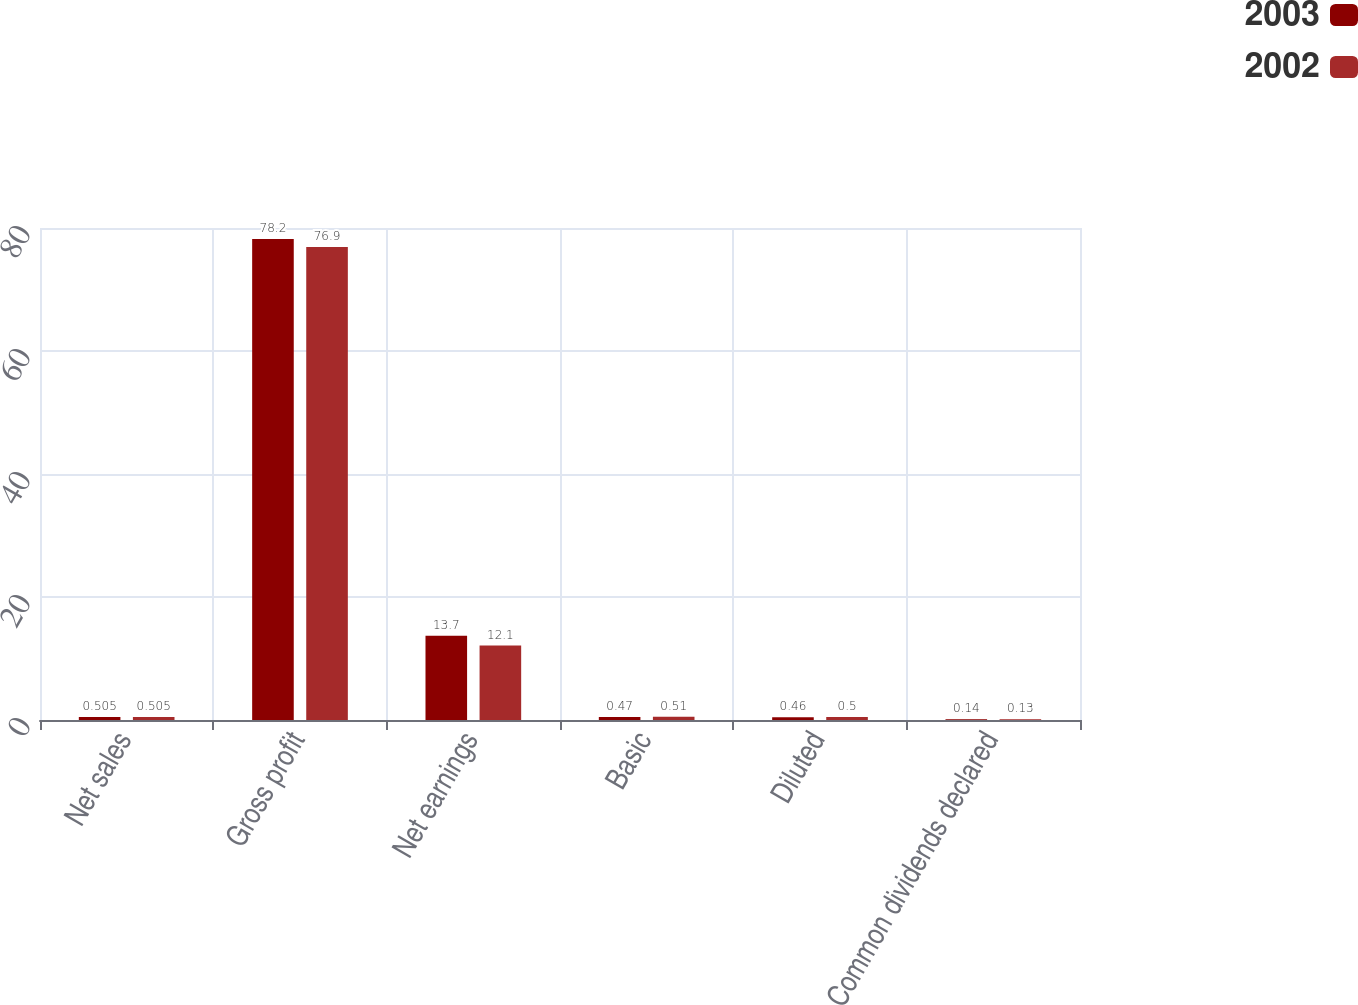Convert chart to OTSL. <chart><loc_0><loc_0><loc_500><loc_500><stacked_bar_chart><ecel><fcel>Net sales<fcel>Gross profit<fcel>Net earnings<fcel>Basic<fcel>Diluted<fcel>Common dividends declared<nl><fcel>2003<fcel>0.505<fcel>78.2<fcel>13.7<fcel>0.47<fcel>0.46<fcel>0.14<nl><fcel>2002<fcel>0.505<fcel>76.9<fcel>12.1<fcel>0.51<fcel>0.5<fcel>0.13<nl></chart> 